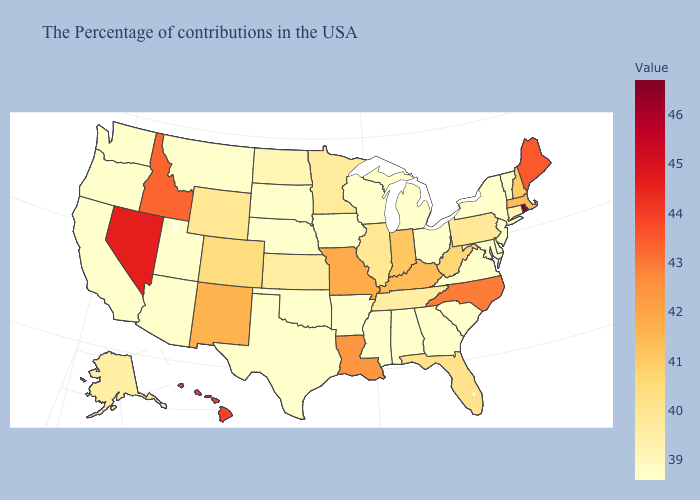Does Rhode Island have the highest value in the USA?
Be succinct. Yes. Which states hav the highest value in the South?
Concise answer only. North Carolina. Does Missouri have the lowest value in the MidWest?
Answer briefly. No. Which states have the lowest value in the USA?
Give a very brief answer. Vermont, New York, New Jersey, Delaware, Maryland, Virginia, South Carolina, Ohio, Georgia, Michigan, Alabama, Wisconsin, Mississippi, Arkansas, Iowa, Nebraska, Oklahoma, Texas, South Dakota, Utah, Montana, Arizona, California, Washington, Oregon. Among the states that border Indiana , does Kentucky have the highest value?
Give a very brief answer. Yes. 